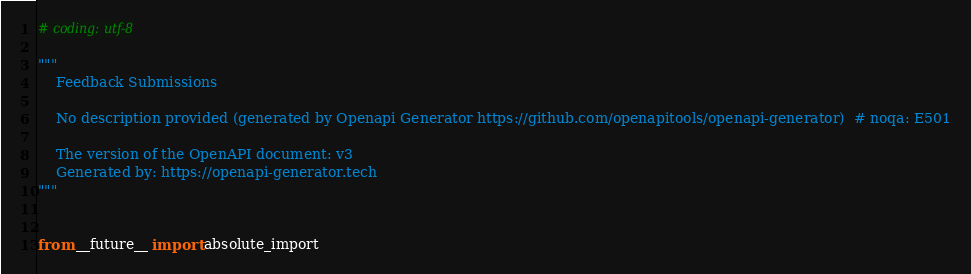Convert code to text. <code><loc_0><loc_0><loc_500><loc_500><_Python_># coding: utf-8

"""
    Feedback Submissions

    No description provided (generated by Openapi Generator https://github.com/openapitools/openapi-generator)  # noqa: E501

    The version of the OpenAPI document: v3
    Generated by: https://openapi-generator.tech
"""


from __future__ import absolute_import
</code> 